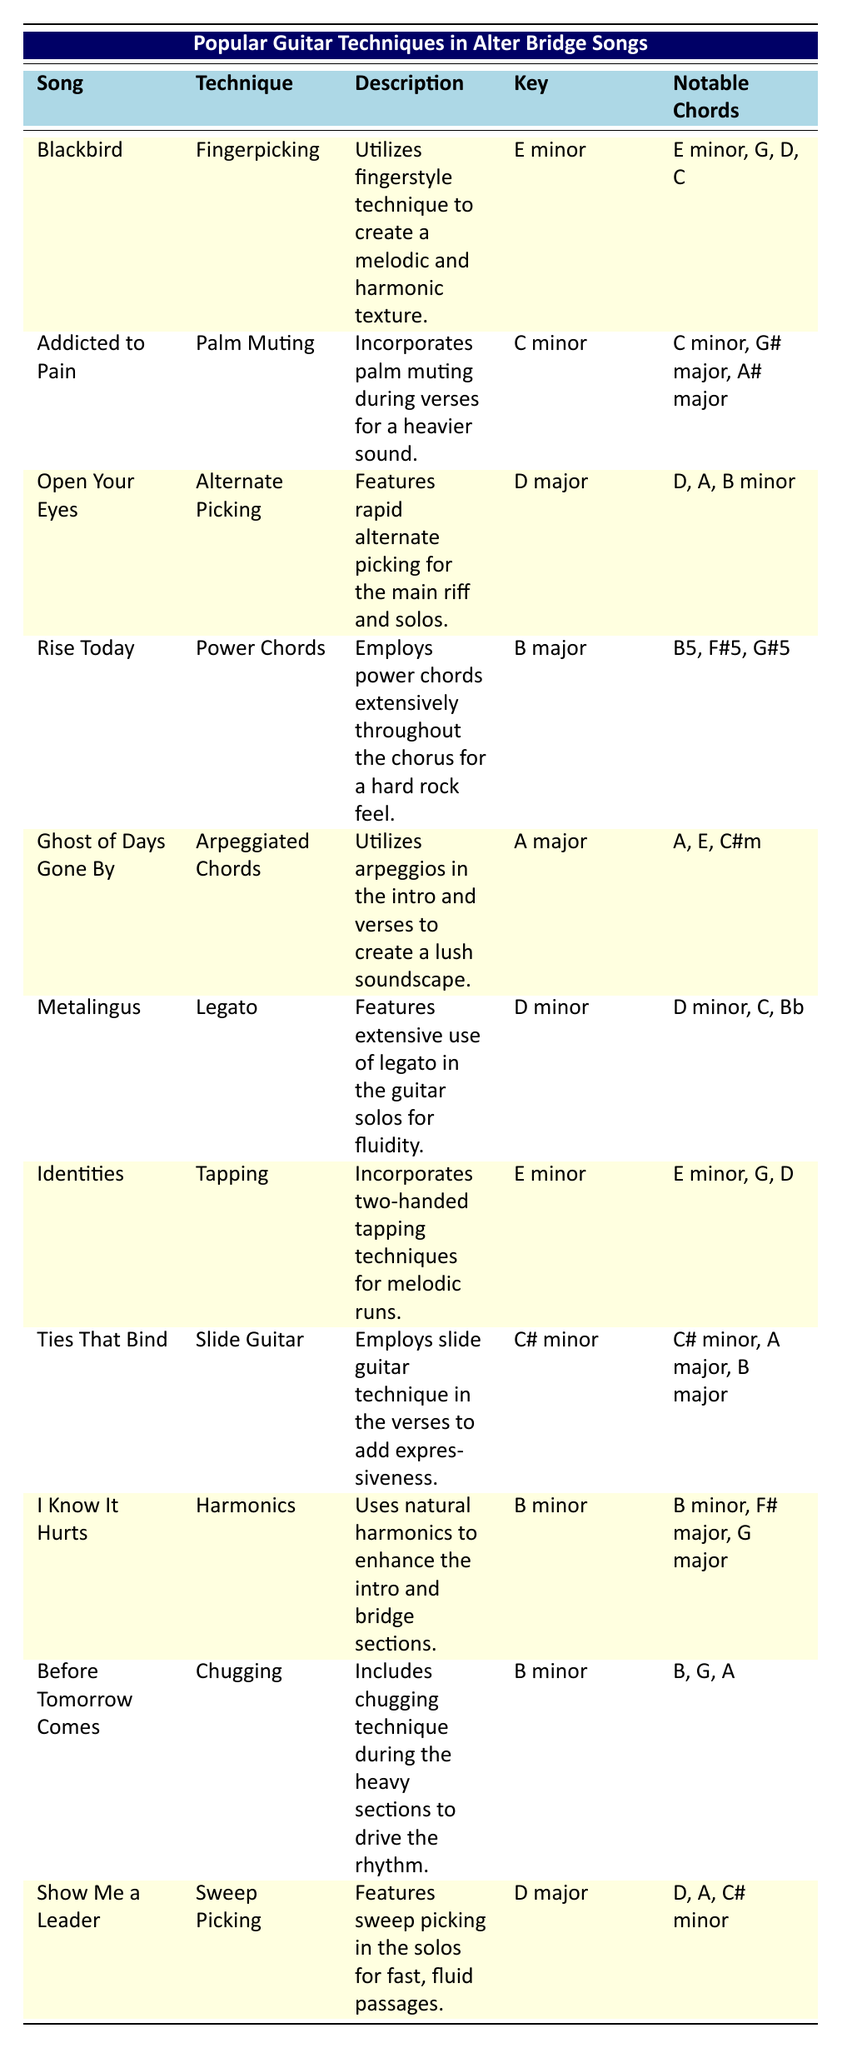What technique is used in "Blackbird"? The table lists "Fingerpicking" as the technique used in the song "Blackbird".
Answer: Fingerpicking What is the key of the song "Open Your Eyes"? According to the table, "Open Your Eyes" is in the key of D major.
Answer: D major Which song features palm muting? The table shows that "Addicted to Pain" incorporates palm muting.
Answer: Addicted to Pain How many songs use the technique of legato? The table indicates that "Metalingus" is the only song featuring legato, so there is just one song.
Answer: 1 Which technique is associated with the song "Ties That Bind"? The technique for "Ties That Bind" is "Slide Guitar" as mentioned in the table.
Answer: Slide Guitar Are there any songs in the key of B minor? Yes, the table shows two songs, "I Know It Hurts" and "Before Tomorrow Comes," in the key of B minor.
Answer: Yes What are the notable chords for the song "Ghost of Days Gone By"? The notable chords are listed as A, E, and C#m in the table for "Ghost of Days Gone By".
Answer: A, E, C#m Which techniques are utilized in songs with the key of E minor? The songs "Blackbird" and "Identities" use Fingerpicking and Tapping, respectively, in the key of E minor, based on the table.
Answer: Fingerpicking, Tapping How many different techniques are used across all songs listed in the table? By counting each unique technique in the table, we find there are 10 different techniques used in total.
Answer: 10 What is the difference between the number of songs using arpeggiated chords and those using sweep picking? There is one song using arpeggiated chords ("Ghost of Days Gone By") and one using sweep picking ("Show Me a Leader"), hence the difference is 0.
Answer: 0 Which song employs harmonics, and what is its key? The song "I Know It Hurts" employs harmonics, and it is in the key of B minor, as noted in the table.
Answer: I Know It Hurts, B minor What is the common technique used for heavy sections in songs like "Before Tomorrow Comes"? The technique used in "Before Tomorrow Comes" during heavy sections is "Chugging".
Answer: Chugging How many songs are there in the key of D major? The table indicates that there are two songs in D major: "Open Your Eyes" and "Show Me a Leader."
Answer: 2 